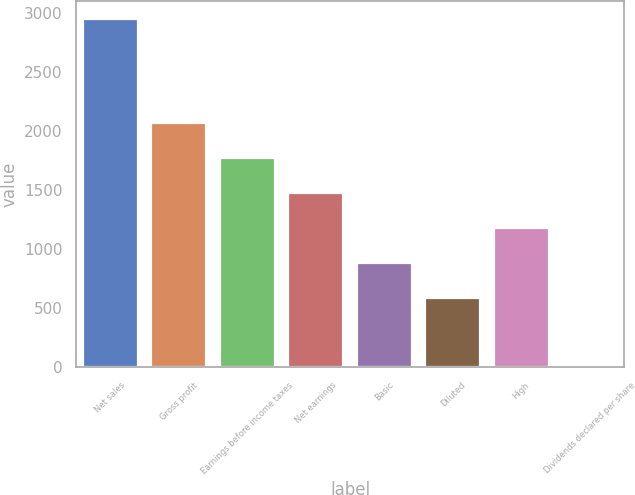Convert chart to OTSL. <chart><loc_0><loc_0><loc_500><loc_500><bar_chart><fcel>Net sales<fcel>Gross profit<fcel>Earnings before income taxes<fcel>Net earnings<fcel>Basic<fcel>Diluted<fcel>High<fcel>Dividends declared per share<nl><fcel>2955<fcel>2068.6<fcel>1773.14<fcel>1477.68<fcel>886.76<fcel>591.3<fcel>1182.22<fcel>0.38<nl></chart> 